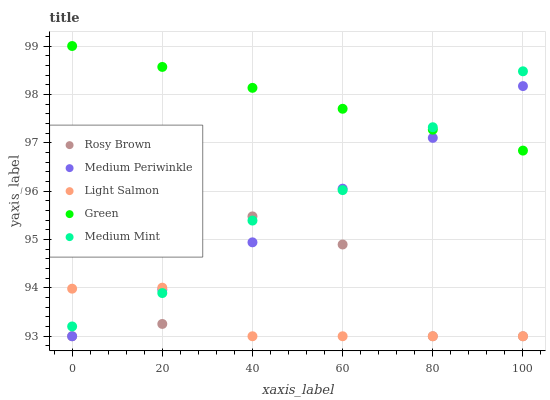Does Light Salmon have the minimum area under the curve?
Answer yes or no. Yes. Does Green have the maximum area under the curve?
Answer yes or no. Yes. Does Green have the minimum area under the curve?
Answer yes or no. No. Does Light Salmon have the maximum area under the curve?
Answer yes or no. No. Is Green the smoothest?
Answer yes or no. Yes. Is Rosy Brown the roughest?
Answer yes or no. Yes. Is Light Salmon the smoothest?
Answer yes or no. No. Is Light Salmon the roughest?
Answer yes or no. No. Does Light Salmon have the lowest value?
Answer yes or no. Yes. Does Green have the lowest value?
Answer yes or no. No. Does Green have the highest value?
Answer yes or no. Yes. Does Light Salmon have the highest value?
Answer yes or no. No. Is Light Salmon less than Green?
Answer yes or no. Yes. Is Green greater than Rosy Brown?
Answer yes or no. Yes. Does Light Salmon intersect Medium Periwinkle?
Answer yes or no. Yes. Is Light Salmon less than Medium Periwinkle?
Answer yes or no. No. Is Light Salmon greater than Medium Periwinkle?
Answer yes or no. No. Does Light Salmon intersect Green?
Answer yes or no. No. 